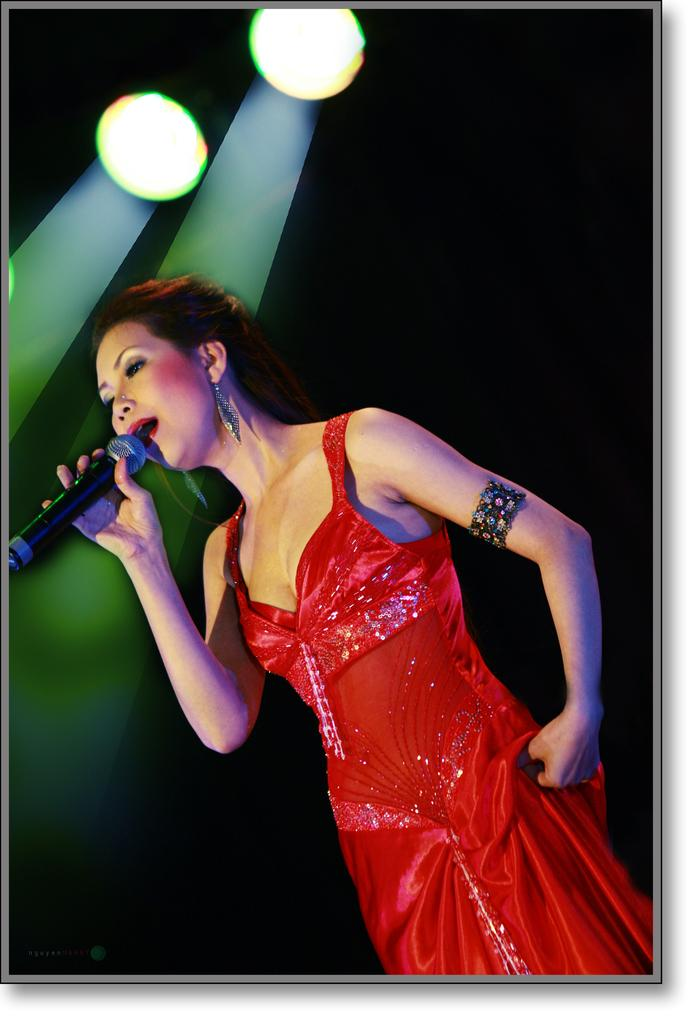Who is the main subject in the image? There is a woman in the image. What is the woman wearing? The woman is wearing a red dress. What is the woman holding in the image? The woman is holding a microphone. What is the woman doing in the image? The woman is singing. What can be seen in the background of the image? There are lights visible in the image. Where is the toothbrush located in the image? There is no toothbrush present in the image. What type of desk is visible in the image? There is no desk present in the image. 